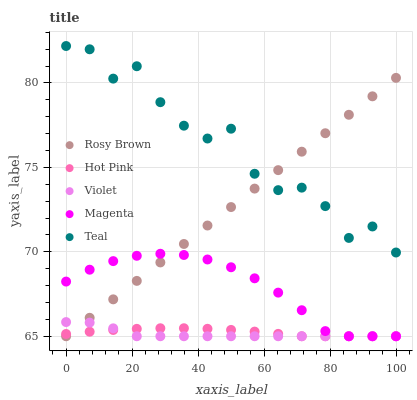Does Violet have the minimum area under the curve?
Answer yes or no. Yes. Does Teal have the maximum area under the curve?
Answer yes or no. Yes. Does Magenta have the minimum area under the curve?
Answer yes or no. No. Does Magenta have the maximum area under the curve?
Answer yes or no. No. Is Rosy Brown the smoothest?
Answer yes or no. Yes. Is Teal the roughest?
Answer yes or no. Yes. Is Magenta the smoothest?
Answer yes or no. No. Is Magenta the roughest?
Answer yes or no. No. Does Violet have the lowest value?
Answer yes or no. Yes. Does Teal have the lowest value?
Answer yes or no. No. Does Teal have the highest value?
Answer yes or no. Yes. Does Magenta have the highest value?
Answer yes or no. No. Is Magenta less than Teal?
Answer yes or no. Yes. Is Teal greater than Violet?
Answer yes or no. Yes. Does Violet intersect Magenta?
Answer yes or no. Yes. Is Violet less than Magenta?
Answer yes or no. No. Is Violet greater than Magenta?
Answer yes or no. No. Does Magenta intersect Teal?
Answer yes or no. No. 